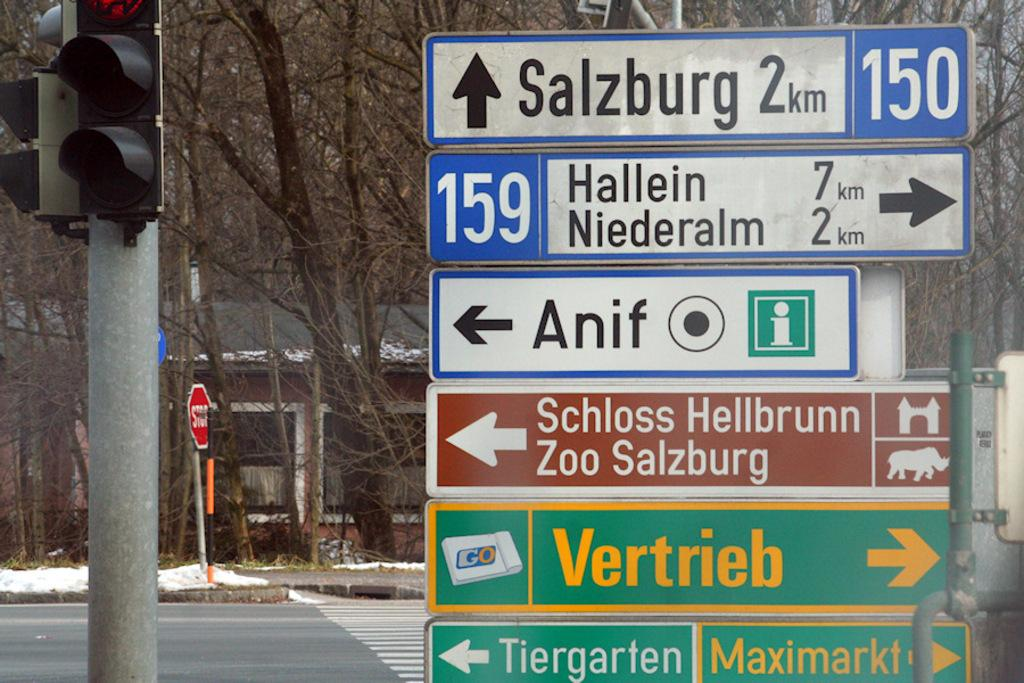<image>
Render a clear and concise summary of the photo. Several road signs point in different directions, one towards Anif 